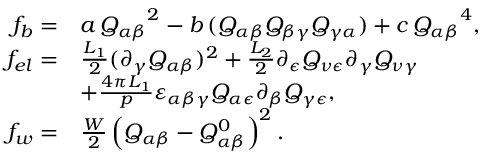Convert formula to latex. <formula><loc_0><loc_0><loc_500><loc_500>\begin{array} { r l } { f _ { b } = } & { a \, { Q _ { \alpha \beta } } ^ { 2 } - b \, ( Q _ { \alpha \beta } Q _ { \beta \gamma } Q _ { \gamma \alpha } ) + c \, { Q _ { \alpha \beta } } ^ { 4 } , } \\ { f _ { e l } = } & { \frac { L _ { 1 } } { 2 } ( \partial _ { \gamma } Q _ { \alpha \beta } ) ^ { 2 } + \frac { L _ { 2 } } { 2 } \partial _ { \epsilon } Q _ { \nu \epsilon } \partial _ { \gamma } Q _ { \nu \gamma } } \\ & { + \frac { 4 \pi L _ { 1 } } { p } \varepsilon _ { \alpha \beta \gamma } Q _ { \alpha \epsilon } \partial _ { \beta } Q _ { \gamma \epsilon } , } \\ { f _ { w } = } & { \frac { W } { 2 } \left ( Q _ { \alpha \beta } - Q _ { \alpha \beta } ^ { 0 } \right ) ^ { 2 } . } \end{array}</formula> 